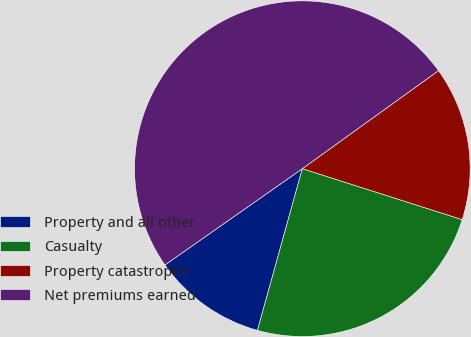<chart> <loc_0><loc_0><loc_500><loc_500><pie_chart><fcel>Property and all other<fcel>Casualty<fcel>Property catastrophe<fcel>Net premiums earned<nl><fcel>10.96%<fcel>24.4%<fcel>14.84%<fcel>49.8%<nl></chart> 